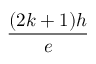<formula> <loc_0><loc_0><loc_500><loc_500>\frac { ( 2 k + 1 ) h } { e }</formula> 